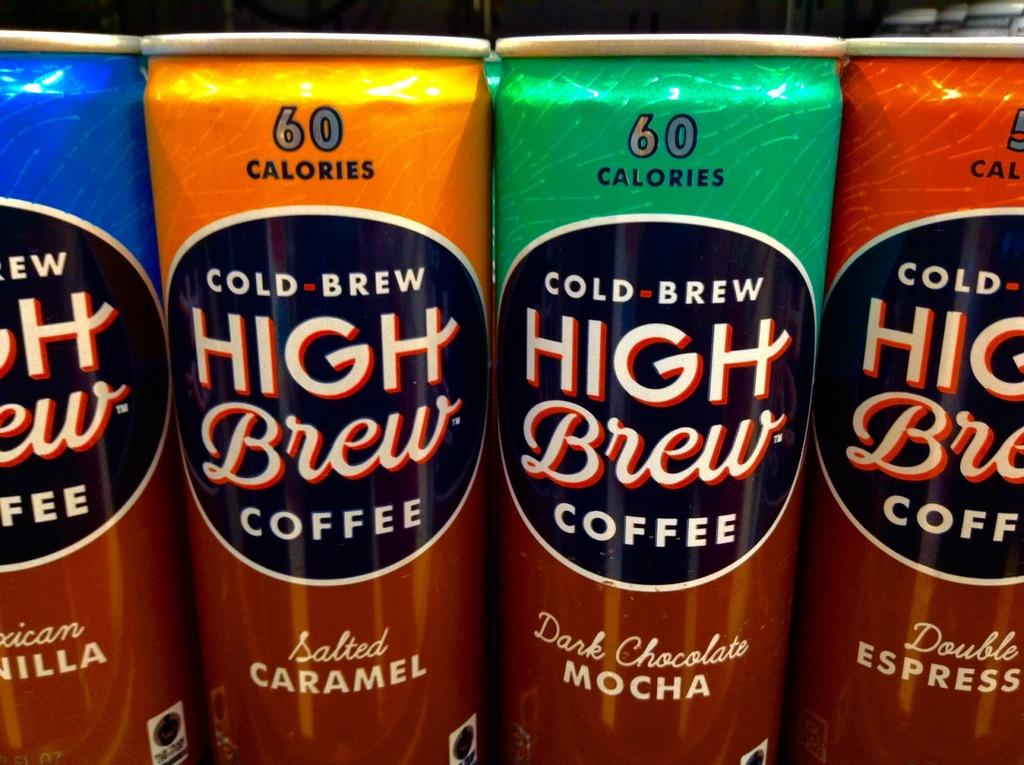What flavors are available from this beer company?
Offer a very short reply. Salted caramel, dark chocolate mocha. How many calories in a can?
Provide a short and direct response. 60. 